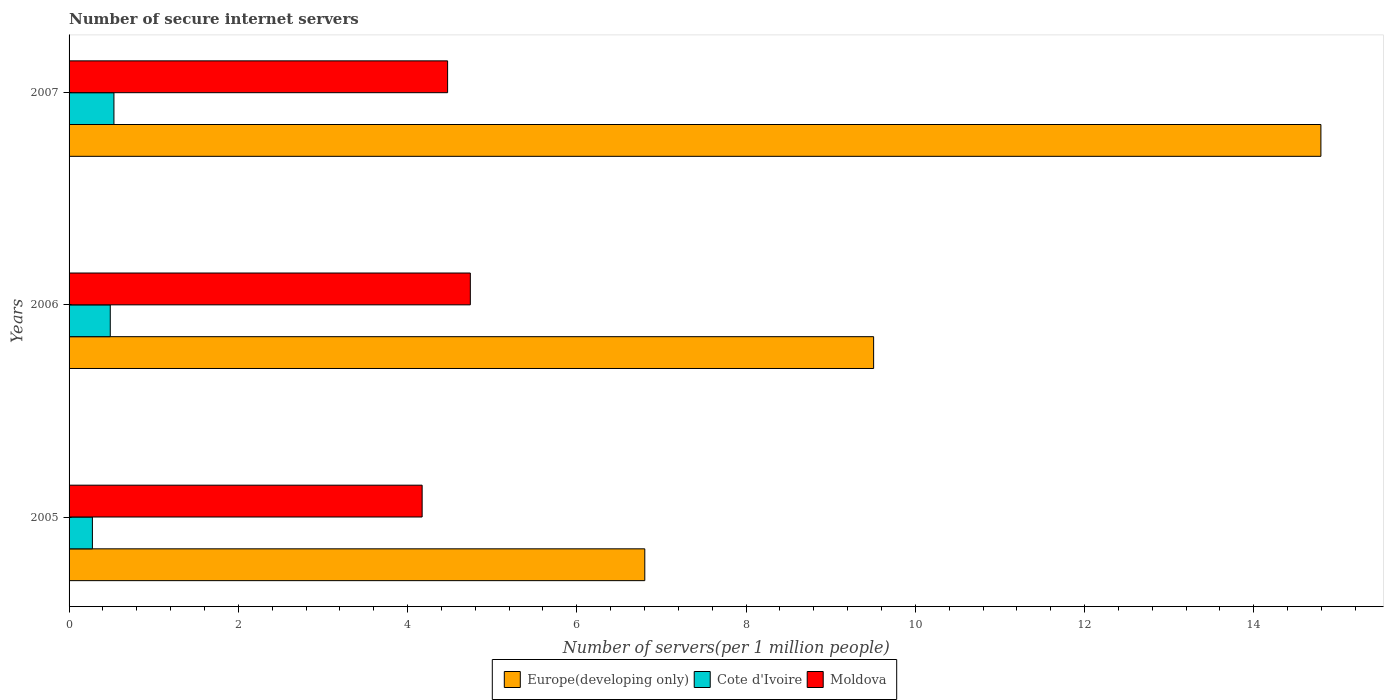How many different coloured bars are there?
Provide a short and direct response. 3. Are the number of bars on each tick of the Y-axis equal?
Your answer should be very brief. Yes. How many bars are there on the 1st tick from the top?
Provide a succinct answer. 3. What is the label of the 2nd group of bars from the top?
Your answer should be very brief. 2006. In how many cases, is the number of bars for a given year not equal to the number of legend labels?
Your response must be concise. 0. What is the number of secure internet servers in Moldova in 2007?
Ensure brevity in your answer.  4.47. Across all years, what is the maximum number of secure internet servers in Europe(developing only)?
Provide a short and direct response. 14.79. Across all years, what is the minimum number of secure internet servers in Cote d'Ivoire?
Ensure brevity in your answer.  0.28. What is the total number of secure internet servers in Moldova in the graph?
Provide a succinct answer. 13.39. What is the difference between the number of secure internet servers in Europe(developing only) in 2005 and that in 2006?
Give a very brief answer. -2.7. What is the difference between the number of secure internet servers in Moldova in 2005 and the number of secure internet servers in Cote d'Ivoire in 2007?
Provide a succinct answer. 3.64. What is the average number of secure internet servers in Moldova per year?
Your response must be concise. 4.46. In the year 2007, what is the difference between the number of secure internet servers in Cote d'Ivoire and number of secure internet servers in Europe(developing only)?
Your answer should be compact. -14.26. What is the ratio of the number of secure internet servers in Cote d'Ivoire in 2005 to that in 2007?
Keep it short and to the point. 0.52. Is the number of secure internet servers in Europe(developing only) in 2005 less than that in 2007?
Keep it short and to the point. Yes. Is the difference between the number of secure internet servers in Cote d'Ivoire in 2005 and 2007 greater than the difference between the number of secure internet servers in Europe(developing only) in 2005 and 2007?
Offer a terse response. Yes. What is the difference between the highest and the second highest number of secure internet servers in Cote d'Ivoire?
Your response must be concise. 0.04. What is the difference between the highest and the lowest number of secure internet servers in Moldova?
Ensure brevity in your answer.  0.57. In how many years, is the number of secure internet servers in Cote d'Ivoire greater than the average number of secure internet servers in Cote d'Ivoire taken over all years?
Offer a very short reply. 2. Is the sum of the number of secure internet servers in Europe(developing only) in 2005 and 2007 greater than the maximum number of secure internet servers in Cote d'Ivoire across all years?
Keep it short and to the point. Yes. What does the 3rd bar from the top in 2007 represents?
Keep it short and to the point. Europe(developing only). What does the 1st bar from the bottom in 2007 represents?
Your response must be concise. Europe(developing only). Are all the bars in the graph horizontal?
Offer a terse response. Yes. How many years are there in the graph?
Offer a terse response. 3. What is the difference between two consecutive major ticks on the X-axis?
Provide a succinct answer. 2. Are the values on the major ticks of X-axis written in scientific E-notation?
Ensure brevity in your answer.  No. How are the legend labels stacked?
Offer a terse response. Horizontal. What is the title of the graph?
Offer a terse response. Number of secure internet servers. Does "Pakistan" appear as one of the legend labels in the graph?
Provide a short and direct response. No. What is the label or title of the X-axis?
Ensure brevity in your answer.  Number of servers(per 1 million people). What is the label or title of the Y-axis?
Ensure brevity in your answer.  Years. What is the Number of servers(per 1 million people) of Europe(developing only) in 2005?
Offer a terse response. 6.8. What is the Number of servers(per 1 million people) in Cote d'Ivoire in 2005?
Ensure brevity in your answer.  0.28. What is the Number of servers(per 1 million people) of Moldova in 2005?
Make the answer very short. 4.17. What is the Number of servers(per 1 million people) of Europe(developing only) in 2006?
Your answer should be compact. 9.51. What is the Number of servers(per 1 million people) of Cote d'Ivoire in 2006?
Keep it short and to the point. 0.49. What is the Number of servers(per 1 million people) of Moldova in 2006?
Your answer should be compact. 4.74. What is the Number of servers(per 1 million people) in Europe(developing only) in 2007?
Give a very brief answer. 14.79. What is the Number of servers(per 1 million people) of Cote d'Ivoire in 2007?
Provide a short and direct response. 0.53. What is the Number of servers(per 1 million people) of Moldova in 2007?
Offer a terse response. 4.47. Across all years, what is the maximum Number of servers(per 1 million people) in Europe(developing only)?
Provide a succinct answer. 14.79. Across all years, what is the maximum Number of servers(per 1 million people) of Cote d'Ivoire?
Give a very brief answer. 0.53. Across all years, what is the maximum Number of servers(per 1 million people) in Moldova?
Provide a short and direct response. 4.74. Across all years, what is the minimum Number of servers(per 1 million people) of Europe(developing only)?
Your response must be concise. 6.8. Across all years, what is the minimum Number of servers(per 1 million people) in Cote d'Ivoire?
Give a very brief answer. 0.28. Across all years, what is the minimum Number of servers(per 1 million people) in Moldova?
Offer a terse response. 4.17. What is the total Number of servers(per 1 million people) of Europe(developing only) in the graph?
Keep it short and to the point. 31.1. What is the total Number of servers(per 1 million people) of Cote d'Ivoire in the graph?
Offer a very short reply. 1.29. What is the total Number of servers(per 1 million people) of Moldova in the graph?
Keep it short and to the point. 13.39. What is the difference between the Number of servers(per 1 million people) in Europe(developing only) in 2005 and that in 2006?
Provide a short and direct response. -2.7. What is the difference between the Number of servers(per 1 million people) in Cote d'Ivoire in 2005 and that in 2006?
Your response must be concise. -0.21. What is the difference between the Number of servers(per 1 million people) in Moldova in 2005 and that in 2006?
Your answer should be compact. -0.57. What is the difference between the Number of servers(per 1 million people) of Europe(developing only) in 2005 and that in 2007?
Your answer should be compact. -7.99. What is the difference between the Number of servers(per 1 million people) in Cote d'Ivoire in 2005 and that in 2007?
Make the answer very short. -0.25. What is the difference between the Number of servers(per 1 million people) in Moldova in 2005 and that in 2007?
Provide a succinct answer. -0.3. What is the difference between the Number of servers(per 1 million people) in Europe(developing only) in 2006 and that in 2007?
Provide a succinct answer. -5.29. What is the difference between the Number of servers(per 1 million people) in Cote d'Ivoire in 2006 and that in 2007?
Provide a succinct answer. -0.04. What is the difference between the Number of servers(per 1 million people) in Moldova in 2006 and that in 2007?
Your answer should be very brief. 0.27. What is the difference between the Number of servers(per 1 million people) in Europe(developing only) in 2005 and the Number of servers(per 1 million people) in Cote d'Ivoire in 2006?
Your answer should be compact. 6.32. What is the difference between the Number of servers(per 1 million people) of Europe(developing only) in 2005 and the Number of servers(per 1 million people) of Moldova in 2006?
Your answer should be compact. 2.06. What is the difference between the Number of servers(per 1 million people) of Cote d'Ivoire in 2005 and the Number of servers(per 1 million people) of Moldova in 2006?
Offer a very short reply. -4.47. What is the difference between the Number of servers(per 1 million people) of Europe(developing only) in 2005 and the Number of servers(per 1 million people) of Cote d'Ivoire in 2007?
Ensure brevity in your answer.  6.27. What is the difference between the Number of servers(per 1 million people) in Europe(developing only) in 2005 and the Number of servers(per 1 million people) in Moldova in 2007?
Keep it short and to the point. 2.33. What is the difference between the Number of servers(per 1 million people) of Cote d'Ivoire in 2005 and the Number of servers(per 1 million people) of Moldova in 2007?
Your answer should be very brief. -4.2. What is the difference between the Number of servers(per 1 million people) of Europe(developing only) in 2006 and the Number of servers(per 1 million people) of Cote d'Ivoire in 2007?
Ensure brevity in your answer.  8.98. What is the difference between the Number of servers(per 1 million people) in Europe(developing only) in 2006 and the Number of servers(per 1 million people) in Moldova in 2007?
Your answer should be compact. 5.03. What is the difference between the Number of servers(per 1 million people) of Cote d'Ivoire in 2006 and the Number of servers(per 1 million people) of Moldova in 2007?
Offer a terse response. -3.99. What is the average Number of servers(per 1 million people) of Europe(developing only) per year?
Your answer should be very brief. 10.37. What is the average Number of servers(per 1 million people) in Cote d'Ivoire per year?
Offer a terse response. 0.43. What is the average Number of servers(per 1 million people) in Moldova per year?
Offer a very short reply. 4.46. In the year 2005, what is the difference between the Number of servers(per 1 million people) in Europe(developing only) and Number of servers(per 1 million people) in Cote d'Ivoire?
Offer a very short reply. 6.53. In the year 2005, what is the difference between the Number of servers(per 1 million people) of Europe(developing only) and Number of servers(per 1 million people) of Moldova?
Your response must be concise. 2.63. In the year 2005, what is the difference between the Number of servers(per 1 million people) in Cote d'Ivoire and Number of servers(per 1 million people) in Moldova?
Your answer should be compact. -3.9. In the year 2006, what is the difference between the Number of servers(per 1 million people) of Europe(developing only) and Number of servers(per 1 million people) of Cote d'Ivoire?
Offer a very short reply. 9.02. In the year 2006, what is the difference between the Number of servers(per 1 million people) of Europe(developing only) and Number of servers(per 1 million people) of Moldova?
Your answer should be compact. 4.77. In the year 2006, what is the difference between the Number of servers(per 1 million people) of Cote d'Ivoire and Number of servers(per 1 million people) of Moldova?
Your answer should be compact. -4.25. In the year 2007, what is the difference between the Number of servers(per 1 million people) of Europe(developing only) and Number of servers(per 1 million people) of Cote d'Ivoire?
Provide a succinct answer. 14.26. In the year 2007, what is the difference between the Number of servers(per 1 million people) in Europe(developing only) and Number of servers(per 1 million people) in Moldova?
Ensure brevity in your answer.  10.32. In the year 2007, what is the difference between the Number of servers(per 1 million people) in Cote d'Ivoire and Number of servers(per 1 million people) in Moldova?
Your answer should be very brief. -3.94. What is the ratio of the Number of servers(per 1 million people) in Europe(developing only) in 2005 to that in 2006?
Keep it short and to the point. 0.72. What is the ratio of the Number of servers(per 1 million people) in Cote d'Ivoire in 2005 to that in 2006?
Ensure brevity in your answer.  0.57. What is the ratio of the Number of servers(per 1 million people) of Moldova in 2005 to that in 2006?
Keep it short and to the point. 0.88. What is the ratio of the Number of servers(per 1 million people) of Europe(developing only) in 2005 to that in 2007?
Give a very brief answer. 0.46. What is the ratio of the Number of servers(per 1 million people) of Cote d'Ivoire in 2005 to that in 2007?
Your response must be concise. 0.52. What is the ratio of the Number of servers(per 1 million people) in Moldova in 2005 to that in 2007?
Make the answer very short. 0.93. What is the ratio of the Number of servers(per 1 million people) in Europe(developing only) in 2006 to that in 2007?
Provide a short and direct response. 0.64. What is the ratio of the Number of servers(per 1 million people) of Cote d'Ivoire in 2006 to that in 2007?
Offer a very short reply. 0.92. What is the ratio of the Number of servers(per 1 million people) in Moldova in 2006 to that in 2007?
Keep it short and to the point. 1.06. What is the difference between the highest and the second highest Number of servers(per 1 million people) in Europe(developing only)?
Offer a terse response. 5.29. What is the difference between the highest and the second highest Number of servers(per 1 million people) of Cote d'Ivoire?
Give a very brief answer. 0.04. What is the difference between the highest and the second highest Number of servers(per 1 million people) of Moldova?
Your response must be concise. 0.27. What is the difference between the highest and the lowest Number of servers(per 1 million people) in Europe(developing only)?
Offer a terse response. 7.99. What is the difference between the highest and the lowest Number of servers(per 1 million people) in Cote d'Ivoire?
Provide a succinct answer. 0.25. What is the difference between the highest and the lowest Number of servers(per 1 million people) in Moldova?
Your response must be concise. 0.57. 